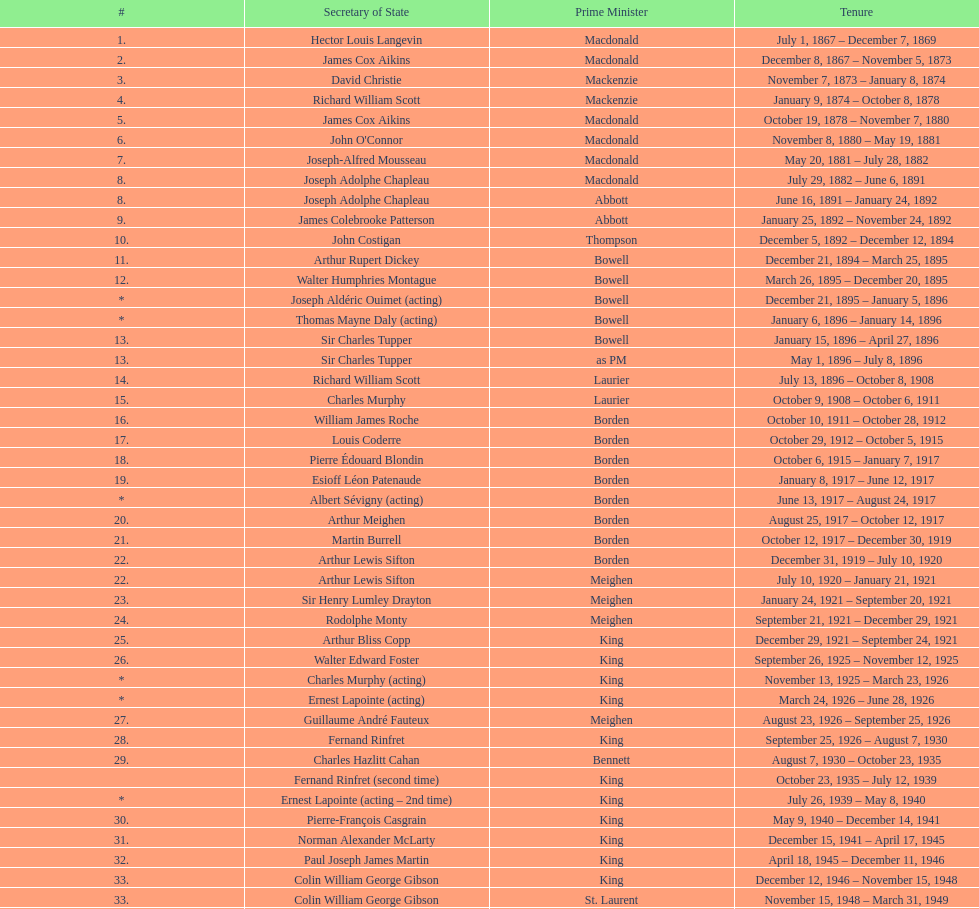Help me parse the entirety of this table. {'header': ['#', 'Secretary of State', 'Prime Minister', 'Tenure'], 'rows': [['1.', 'Hector Louis Langevin', 'Macdonald', 'July 1, 1867 – December 7, 1869'], ['2.', 'James Cox Aikins', 'Macdonald', 'December 8, 1867 – November 5, 1873'], ['3.', 'David Christie', 'Mackenzie', 'November 7, 1873 – January 8, 1874'], ['4.', 'Richard William Scott', 'Mackenzie', 'January 9, 1874 – October 8, 1878'], ['5.', 'James Cox Aikins', 'Macdonald', 'October 19, 1878 – November 7, 1880'], ['6.', "John O'Connor", 'Macdonald', 'November 8, 1880 – May 19, 1881'], ['7.', 'Joseph-Alfred Mousseau', 'Macdonald', 'May 20, 1881 – July 28, 1882'], ['8.', 'Joseph Adolphe Chapleau', 'Macdonald', 'July 29, 1882 – June 6, 1891'], ['8.', 'Joseph Adolphe Chapleau', 'Abbott', 'June 16, 1891 – January 24, 1892'], ['9.', 'James Colebrooke Patterson', 'Abbott', 'January 25, 1892 – November 24, 1892'], ['10.', 'John Costigan', 'Thompson', 'December 5, 1892 – December 12, 1894'], ['11.', 'Arthur Rupert Dickey', 'Bowell', 'December 21, 1894 – March 25, 1895'], ['12.', 'Walter Humphries Montague', 'Bowell', 'March 26, 1895 – December 20, 1895'], ['*', 'Joseph Aldéric Ouimet (acting)', 'Bowell', 'December 21, 1895 – January 5, 1896'], ['*', 'Thomas Mayne Daly (acting)', 'Bowell', 'January 6, 1896 – January 14, 1896'], ['13.', 'Sir Charles Tupper', 'Bowell', 'January 15, 1896 – April 27, 1896'], ['13.', 'Sir Charles Tupper', 'as PM', 'May 1, 1896 – July 8, 1896'], ['14.', 'Richard William Scott', 'Laurier', 'July 13, 1896 – October 8, 1908'], ['15.', 'Charles Murphy', 'Laurier', 'October 9, 1908 – October 6, 1911'], ['16.', 'William James Roche', 'Borden', 'October 10, 1911 – October 28, 1912'], ['17.', 'Louis Coderre', 'Borden', 'October 29, 1912 – October 5, 1915'], ['18.', 'Pierre Édouard Blondin', 'Borden', 'October 6, 1915 – January 7, 1917'], ['19.', 'Esioff Léon Patenaude', 'Borden', 'January 8, 1917 – June 12, 1917'], ['*', 'Albert Sévigny (acting)', 'Borden', 'June 13, 1917 – August 24, 1917'], ['20.', 'Arthur Meighen', 'Borden', 'August 25, 1917 – October 12, 1917'], ['21.', 'Martin Burrell', 'Borden', 'October 12, 1917 – December 30, 1919'], ['22.', 'Arthur Lewis Sifton', 'Borden', 'December 31, 1919 – July 10, 1920'], ['22.', 'Arthur Lewis Sifton', 'Meighen', 'July 10, 1920 – January 21, 1921'], ['23.', 'Sir Henry Lumley Drayton', 'Meighen', 'January 24, 1921 – September 20, 1921'], ['24.', 'Rodolphe Monty', 'Meighen', 'September 21, 1921 – December 29, 1921'], ['25.', 'Arthur Bliss Copp', 'King', 'December 29, 1921 – September 24, 1921'], ['26.', 'Walter Edward Foster', 'King', 'September 26, 1925 – November 12, 1925'], ['*', 'Charles Murphy (acting)', 'King', 'November 13, 1925 – March 23, 1926'], ['*', 'Ernest Lapointe (acting)', 'King', 'March 24, 1926 – June 28, 1926'], ['27.', 'Guillaume André Fauteux', 'Meighen', 'August 23, 1926 – September 25, 1926'], ['28.', 'Fernand Rinfret', 'King', 'September 25, 1926 – August 7, 1930'], ['29.', 'Charles Hazlitt Cahan', 'Bennett', 'August 7, 1930 – October 23, 1935'], ['', 'Fernand Rinfret (second time)', 'King', 'October 23, 1935 – July 12, 1939'], ['*', 'Ernest Lapointe (acting – 2nd time)', 'King', 'July 26, 1939 – May 8, 1940'], ['30.', 'Pierre-François Casgrain', 'King', 'May 9, 1940 – December 14, 1941'], ['31.', 'Norman Alexander McLarty', 'King', 'December 15, 1941 – April 17, 1945'], ['32.', 'Paul Joseph James Martin', 'King', 'April 18, 1945 – December 11, 1946'], ['33.', 'Colin William George Gibson', 'King', 'December 12, 1946 – November 15, 1948'], ['33.', 'Colin William George Gibson', 'St. Laurent', 'November 15, 1948 – March 31, 1949'], ['34.', 'Frederick Gordon Bradley', 'St. Laurent', 'March 31, 1949 – June 11, 1953'], ['35.', 'Jack Pickersgill', 'St. Laurent', 'June 11, 1953 – June 30, 1954'], ['36.', 'Roch Pinard', 'St. Laurent', 'July 1, 1954 – June 21, 1957'], ['37.', 'Ellen Louks Fairclough', 'Diefenbaker', 'June 21, 1957 – May 11, 1958'], ['38.', 'Henri Courtemanche', 'Diefenbaker', 'May 12, 1958 – June 19, 1960'], ['*', 'Léon Balcer (acting minister)', 'Diefenbaker', 'June 21, 1960 – October 10, 1960'], ['39.', 'Noël Dorion', 'Diefenbaker', 'October 11, 1960 – July 5, 1962'], ['*', 'Léon Balcer (acting minister – 2nd time)', 'Diefenbaker', 'July 11, 1962 – August 8, 1962'], ['40.', 'George Ernest Halpenny', 'Diefenbaker', 'August 9, 1962 – April 22, 1963'], ['', 'Jack Pickersgill (second time)', 'Pearson', 'April 22, 1963 – February 2, 1964'], ['41.', 'Maurice Lamontagne', 'Pearson', 'February 2, 1964 – December 17, 1965'], ['42.', 'Judy LaMarsh', 'Pearson', 'December 17, 1965 – April 9, 1968'], ['*', 'John Joseph Connolly (acting minister)', 'Pearson', 'April 10, 1968 – April 20, 1968'], ['43.', 'Jean Marchand', 'Trudeau', 'April 20, 1968 – July 5, 1968'], ['44.', 'Gérard Pelletier', 'Trudeau', 'July 5, 1968 – November 26, 1972'], ['45.', 'James Hugh Faulkner', 'Trudeau', 'November 27, 1972 – September 13, 1976'], ['46.', 'John Roberts', 'Trudeau', 'September 14, 1976 – June 3, 1979'], ['47.', 'David MacDonald', 'Clark', 'June 4, 1979 – March 2, 1980'], ['48.', 'Francis Fox', 'Trudeau', 'March 3, 1980 – September 21, 1981'], ['49.', 'Gerald Regan', 'Trudeau', 'September 22, 1981 – October 5, 1982'], ['50.', 'Serge Joyal', 'Trudeau', 'October 6, 1982 – June 29, 1984'], ['50.', 'Serge Joyal', 'Turner', 'June 30, 1984 – September 16, 1984'], ['51.', 'Walter McLean', 'Mulroney', 'September 17, 1984 – April 19, 1985'], ['52.', 'Benoit Bouchard', 'Mulroney', 'April 20, 1985 – June 29, 1986'], ['53.', 'David Crombie', 'Mulroney', 'June 30, 1986 – March 30, 1988'], ['54.', 'Lucien Bouchard', 'Mulroney', 'March 31, 1988 – January 29, 1989'], ['55.', 'Gerry Weiner', 'Mulroney', 'January 30, 1989 – April 20, 1991'], ['56.', 'Robert de Cotret', 'Mulroney', 'April 21, 1991 – January 3, 1993'], ['57.', 'Monique Landry', 'Mulroney', 'January 4, 1993 – June 24, 1993'], ['57.', 'Monique Landry', 'Campbell', 'June 24, 1993 – November 3, 1993'], ['58.', 'Sergio Marchi', 'Chrétien', 'November 4, 1993 – January 24, 1996'], ['59.', 'Lucienne Robillard', 'Chrétien', 'January 25, 1996 – July 12, 1996']]} How many secretaries of state served during prime minister macdonald's tenure? 6. 